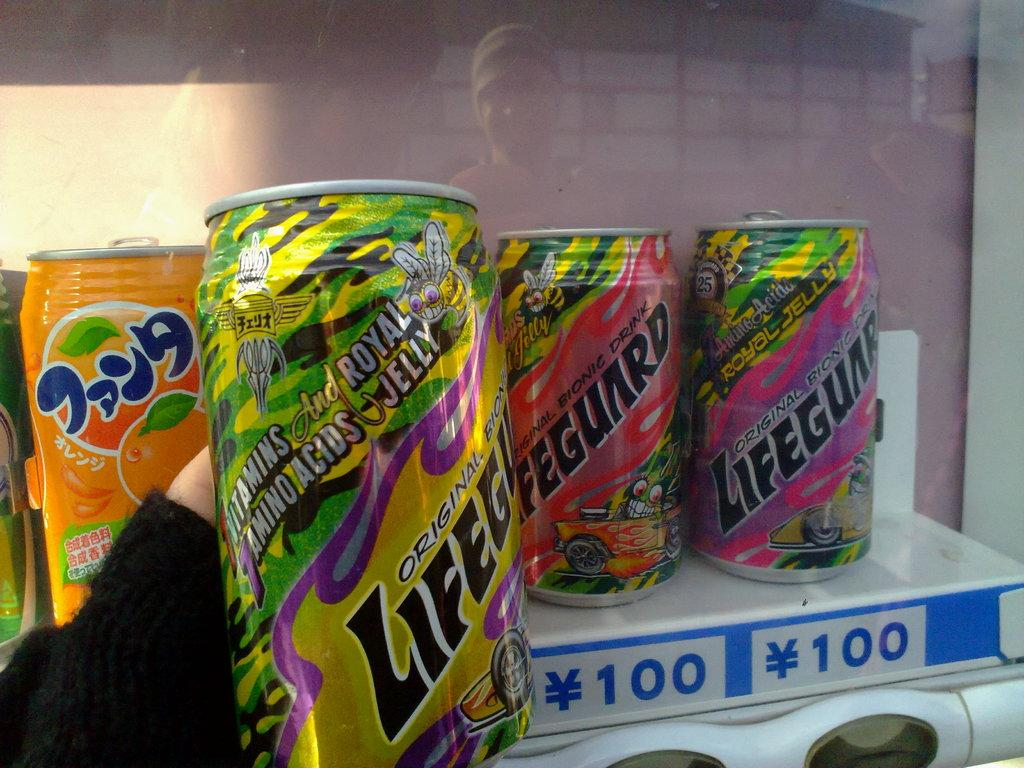<image>
Give a short and clear explanation of the subsequent image. Three beverage cans that have Lifegunrd written on them. 